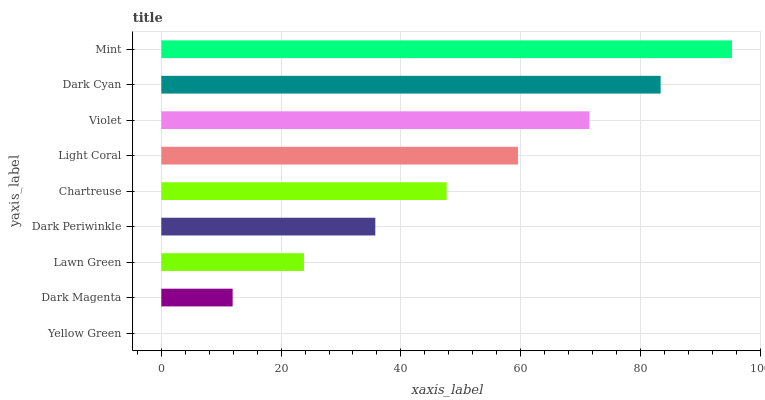Is Yellow Green the minimum?
Answer yes or no. Yes. Is Mint the maximum?
Answer yes or no. Yes. Is Dark Magenta the minimum?
Answer yes or no. No. Is Dark Magenta the maximum?
Answer yes or no. No. Is Dark Magenta greater than Yellow Green?
Answer yes or no. Yes. Is Yellow Green less than Dark Magenta?
Answer yes or no. Yes. Is Yellow Green greater than Dark Magenta?
Answer yes or no. No. Is Dark Magenta less than Yellow Green?
Answer yes or no. No. Is Chartreuse the high median?
Answer yes or no. Yes. Is Chartreuse the low median?
Answer yes or no. Yes. Is Dark Cyan the high median?
Answer yes or no. No. Is Lawn Green the low median?
Answer yes or no. No. 